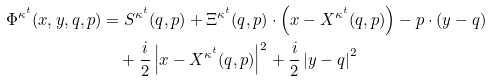<formula> <loc_0><loc_0><loc_500><loc_500>\Phi ^ { \kappa ^ { t } } ( x , y , q , p ) & = S ^ { \kappa ^ { t } } ( q , p ) + \Xi ^ { \kappa ^ { t } } ( q , p ) \cdot \left ( x - X ^ { \kappa ^ { t } } ( q , p ) \right ) - p \cdot ( y - q ) \\ & \quad + \frac { i } { 2 } \left | x - X ^ { \kappa ^ { t } } ( q , p ) \right | ^ { 2 } + \frac { i } { 2 } \left | y - q \right | ^ { 2 }</formula> 